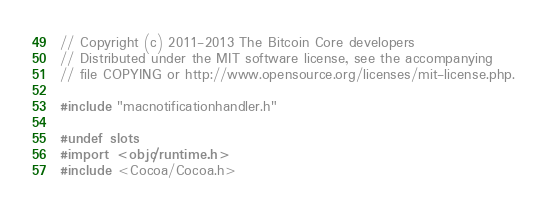Convert code to text. <code><loc_0><loc_0><loc_500><loc_500><_ObjectiveC_>// Copyright (c) 2011-2013 The Bitcoin Core developers
// Distributed under the MIT software license, see the accompanying
// file COPYING or http://www.opensource.org/licenses/mit-license.php.

#include "macnotificationhandler.h"

#undef slots
#import <objc/runtime.h>
#include <Cocoa/Cocoa.h>
</code> 